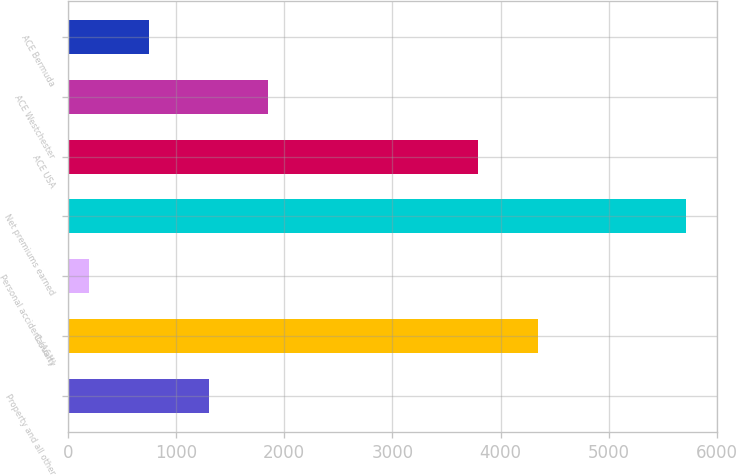<chart> <loc_0><loc_0><loc_500><loc_500><bar_chart><fcel>Property and all other<fcel>Casualty<fcel>Personal accident (A&H)<fcel>Net premiums earned<fcel>ACE USA<fcel>ACE Westchester<fcel>ACE Bermuda<nl><fcel>1299.8<fcel>4347.4<fcel>195<fcel>5719<fcel>3795<fcel>1852.2<fcel>747.4<nl></chart> 